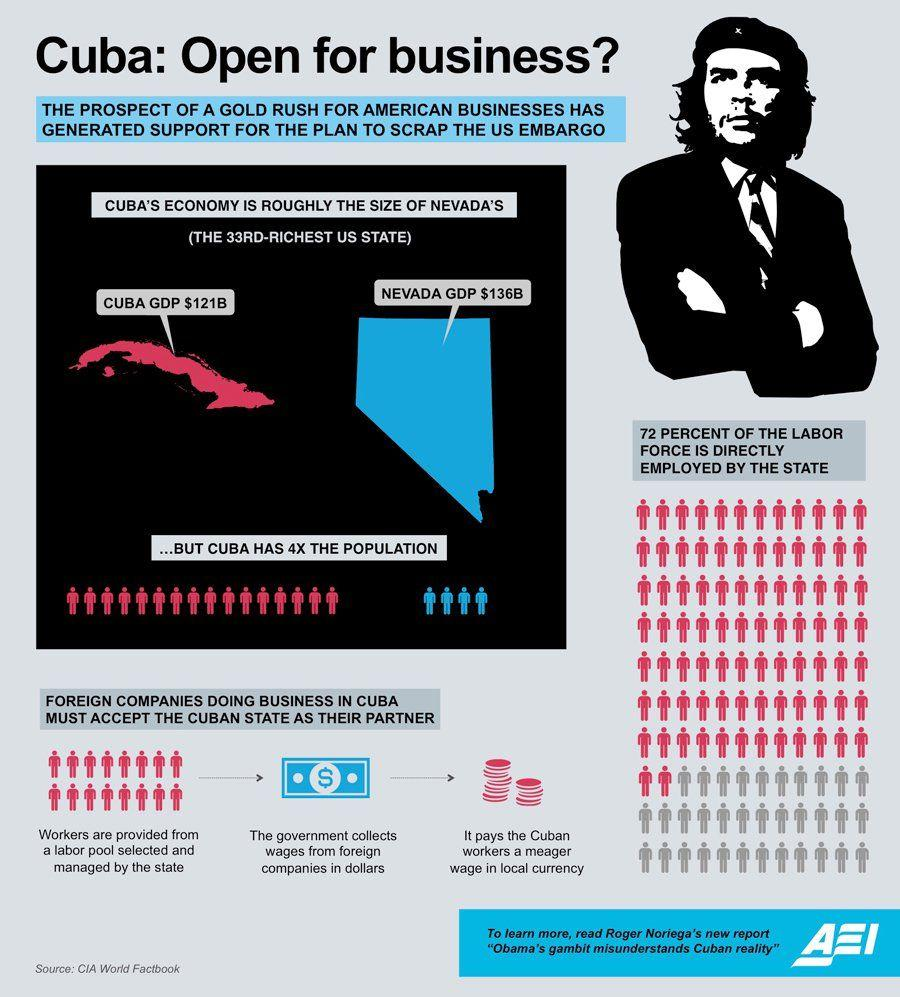Specify some key components in this picture. NEVADA is the 33rd richest state in the United States. Cuba collects dollars from other companies. The population of Cuba is approximately four times larger than that of Nevada. 